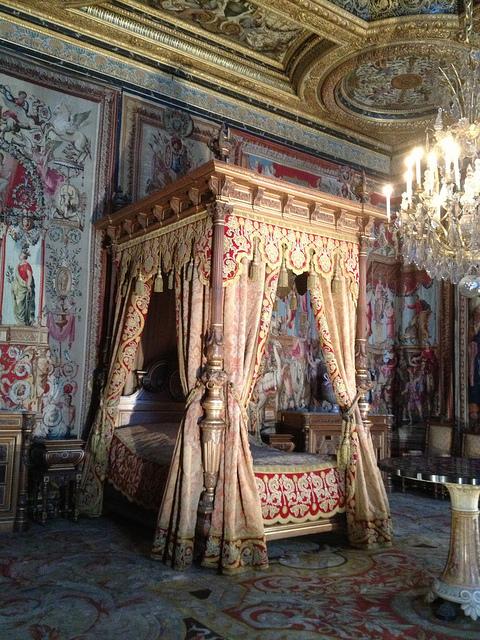Is there a lamp on the nightstand?
Keep it brief. No. Is the carpet the same as the walls?
Give a very brief answer. Yes. How many people are sitting on the bed?
Give a very brief answer. 0. What type of light fixture is present?
Short answer required. Chandelier. 